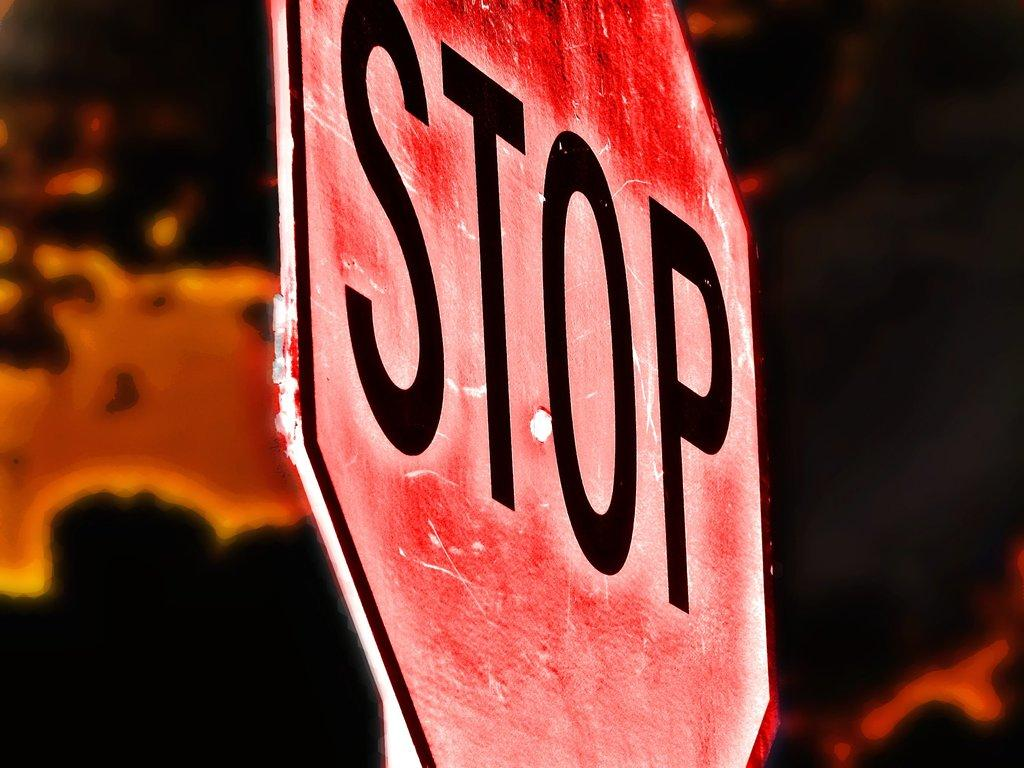<image>
Provide a brief description of the given image. A red sign says Stop in black letters. 